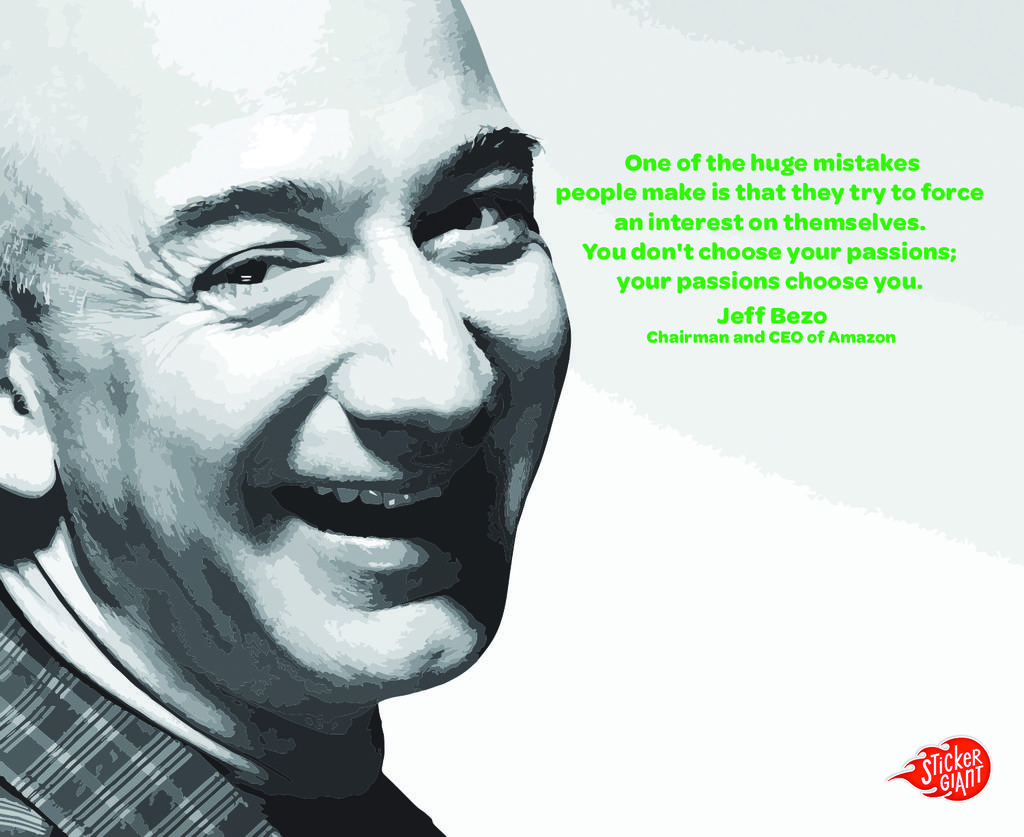What is depicted in the image? The image contains a painting of a person. What can be observed about the person's attire in the painting? The person in the painting is wearing clothes. What is the person's facial expression or action in the painting? The person's mouth is open in the painting, and their teeth are visible. Is there any text present in the image? Yes, there is text written in the image. Is the person in the painting swimming in the snow while being addressed by the governor? There is no indication of swimming, snow, or a governor in the image; it features a painting of a person with an open mouth and visible teeth. 